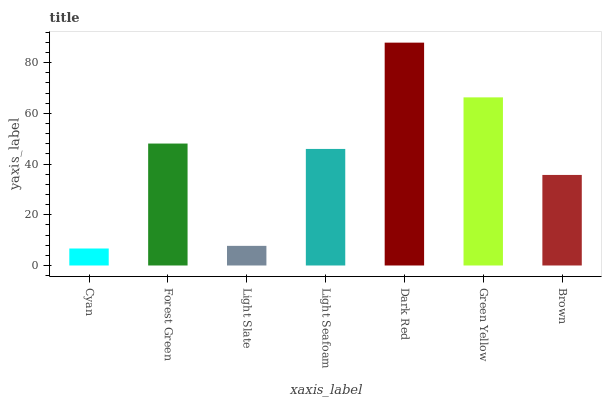Is Cyan the minimum?
Answer yes or no. Yes. Is Dark Red the maximum?
Answer yes or no. Yes. Is Forest Green the minimum?
Answer yes or no. No. Is Forest Green the maximum?
Answer yes or no. No. Is Forest Green greater than Cyan?
Answer yes or no. Yes. Is Cyan less than Forest Green?
Answer yes or no. Yes. Is Cyan greater than Forest Green?
Answer yes or no. No. Is Forest Green less than Cyan?
Answer yes or no. No. Is Light Seafoam the high median?
Answer yes or no. Yes. Is Light Seafoam the low median?
Answer yes or no. Yes. Is Green Yellow the high median?
Answer yes or no. No. Is Dark Red the low median?
Answer yes or no. No. 